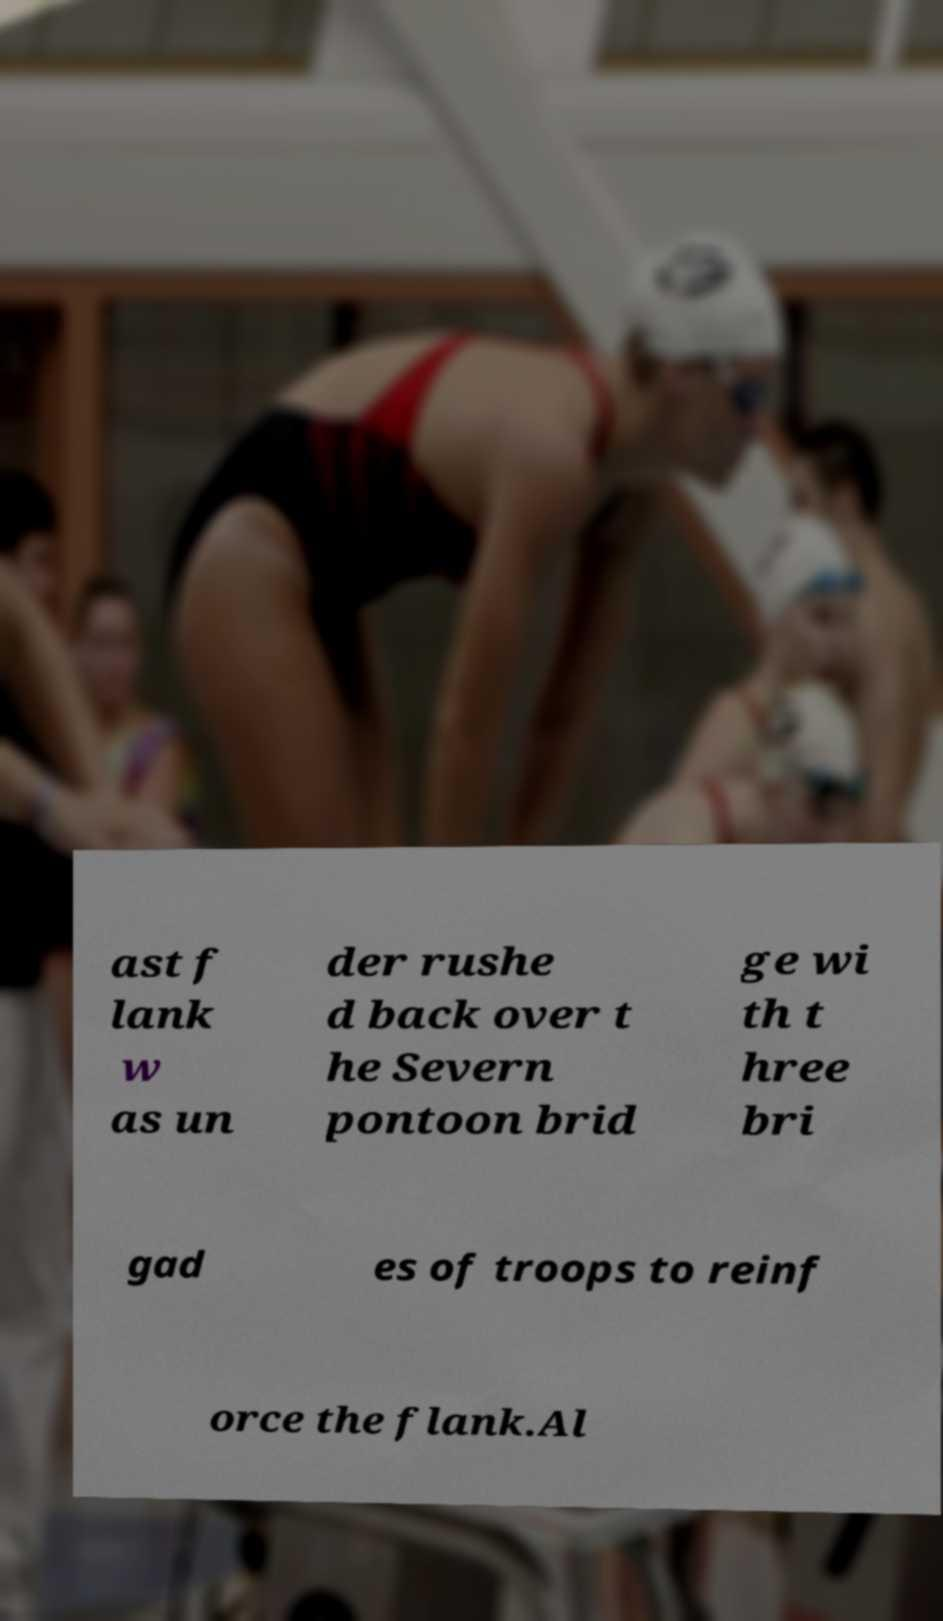Please identify and transcribe the text found in this image. ast f lank w as un der rushe d back over t he Severn pontoon brid ge wi th t hree bri gad es of troops to reinf orce the flank.Al 